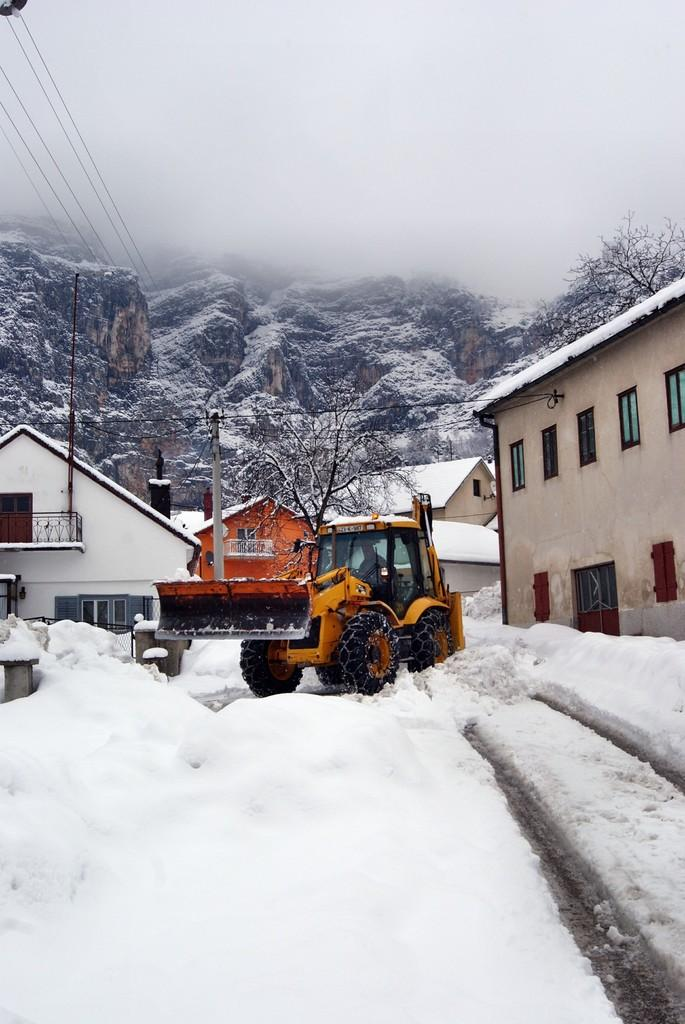What is the person in the image doing? There is a person sitting inside a vehicle in the image. What is the weather like in the image? There is snow visible in the image, indicating a cold or wintry environment. What structures can be seen in the image? There are buildings in the image. What else can be seen in the image besides the person and the buildings? There is a pole, wires, a hill, trees, and the sky visible in the image. What time is displayed on the clock in the image? There is no clock present in the image. How does the person's memory affect the image? The person's memory is not visible or relevant in the image. 